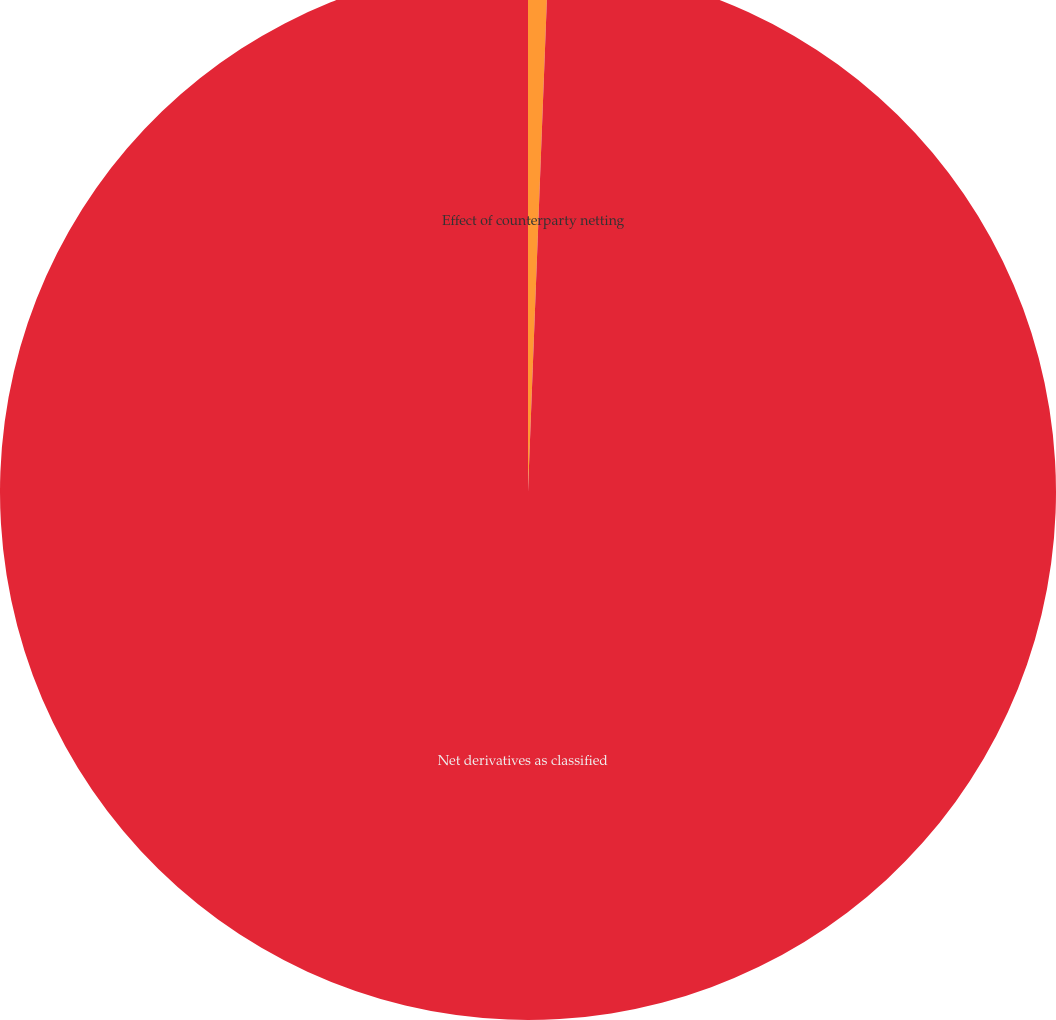Convert chart. <chart><loc_0><loc_0><loc_500><loc_500><pie_chart><fcel>Effect of counterparty netting<fcel>Net derivatives as classified<nl><fcel>0.61%<fcel>99.39%<nl></chart> 